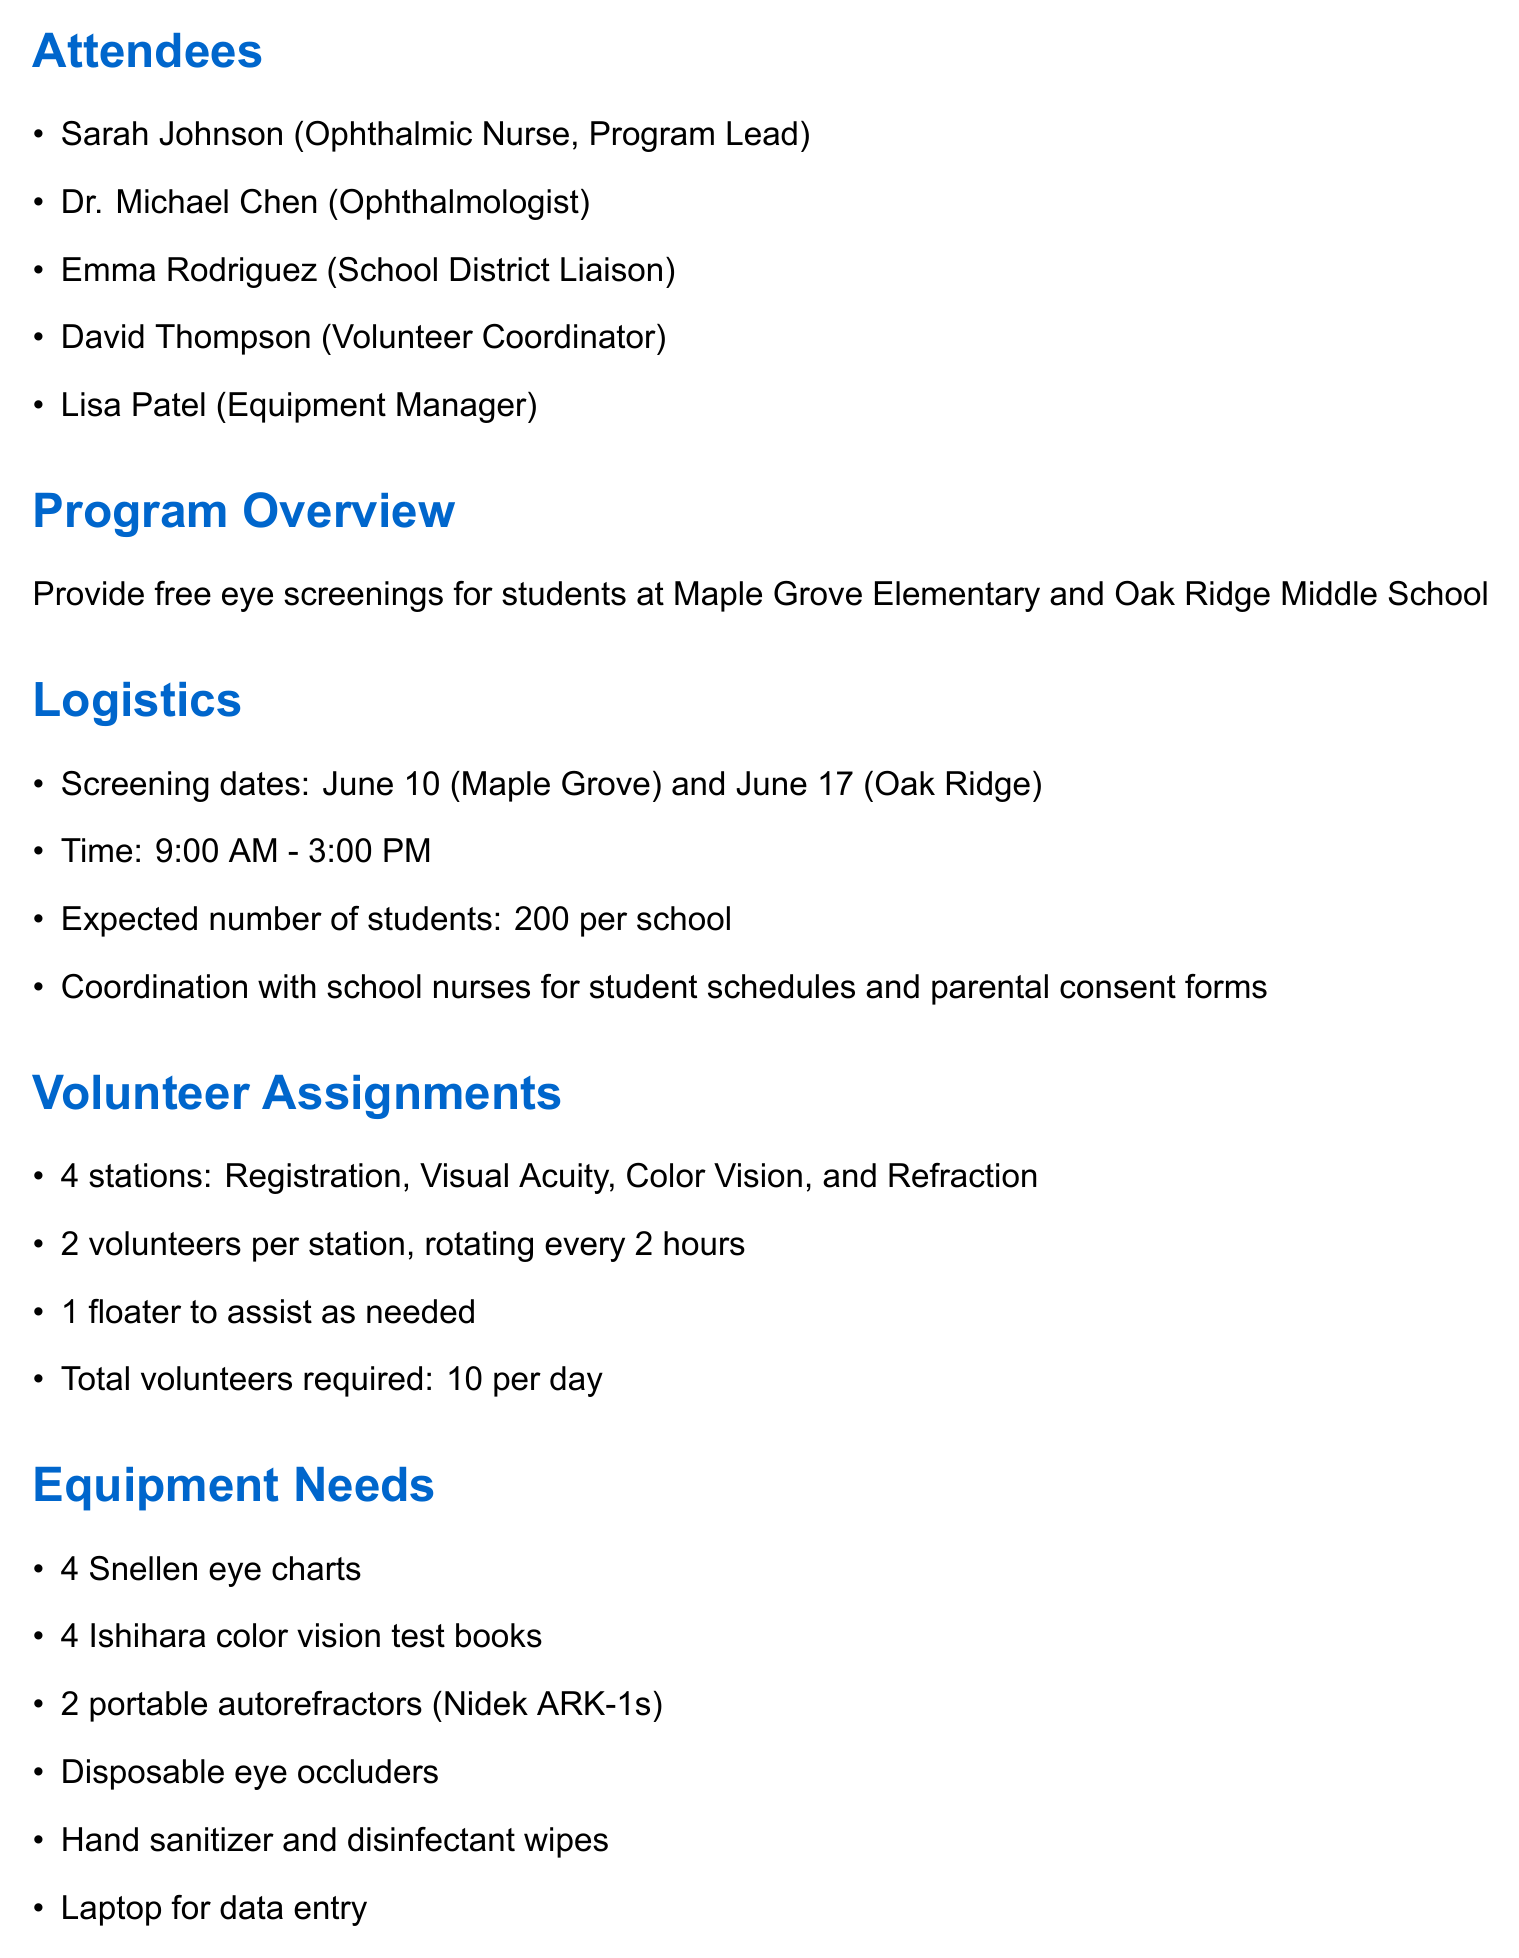what are the screening dates? The document states the screening dates for the schools, which are June 10 for Maple Grove and June 17 for Oak Ridge.
Answer: June 10 and June 17 how many students are expected at each school? The document specifies that 200 students are expected at each school during the screenings.
Answer: 200 who is responsible for confirming equipment availability? According to the action items, Lisa is tasked with confirming the equipment availability and arranging delivery.
Answer: Lisa how many volunteers are required per day? The volunteer assignments outline that a total of 10 volunteers are needed each day for the screenings.
Answer: 10 what is the role of David Thompson? The attendees list includes David Thompson's title, which indicates he is the Volunteer Coordinator for the program.
Answer: Volunteer Coordinator what type of equipment is needed for the screenings? The equipment needs section lists items required for the program, such as eye charts and autorefractors.
Answer: Snellen eye charts, Ishihara color vision test books, portable autorefractors when is the volunteer training session scheduled? The action items state that the volunteer training session is scheduled for June 3.
Answer: June 3 what is the purpose of the outreach program? The program overview outlines the main goal, which is to provide free eye screenings for students.
Answer: Provide free eye screenings how will the screening results be communicated to parents? The follow-up process indicates that screening results will be provided to parents following the screenings.
Answer: Provide screening results to parents 